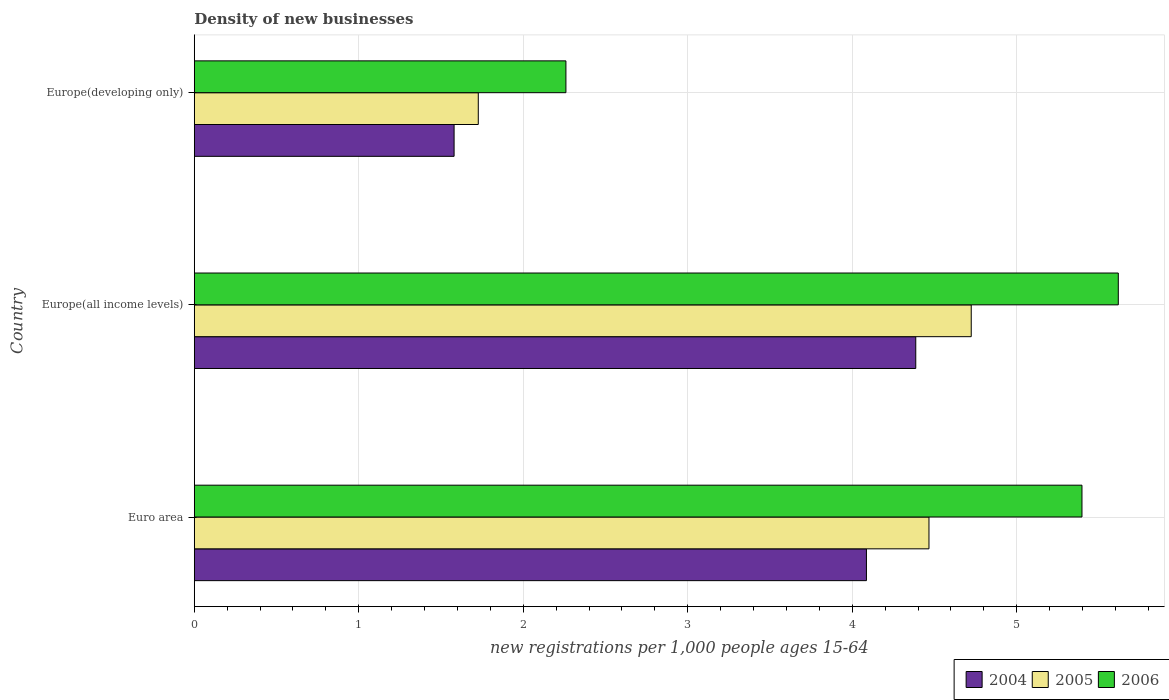How many groups of bars are there?
Make the answer very short. 3. Are the number of bars per tick equal to the number of legend labels?
Your answer should be compact. Yes. Are the number of bars on each tick of the Y-axis equal?
Keep it short and to the point. Yes. What is the label of the 1st group of bars from the top?
Your response must be concise. Europe(developing only). What is the number of new registrations in 2006 in Euro area?
Make the answer very short. 5.4. Across all countries, what is the maximum number of new registrations in 2006?
Provide a succinct answer. 5.62. Across all countries, what is the minimum number of new registrations in 2004?
Provide a short and direct response. 1.58. In which country was the number of new registrations in 2004 maximum?
Keep it short and to the point. Europe(all income levels). In which country was the number of new registrations in 2005 minimum?
Your answer should be very brief. Europe(developing only). What is the total number of new registrations in 2004 in the graph?
Your answer should be compact. 10.05. What is the difference between the number of new registrations in 2006 in Euro area and that in Europe(developing only)?
Provide a succinct answer. 3.14. What is the difference between the number of new registrations in 2005 in Euro area and the number of new registrations in 2004 in Europe(all income levels)?
Your answer should be very brief. 0.08. What is the average number of new registrations in 2006 per country?
Give a very brief answer. 4.42. What is the difference between the number of new registrations in 2005 and number of new registrations in 2006 in Europe(all income levels)?
Provide a succinct answer. -0.89. What is the ratio of the number of new registrations in 2006 in Europe(all income levels) to that in Europe(developing only)?
Your response must be concise. 2.49. Is the difference between the number of new registrations in 2005 in Europe(all income levels) and Europe(developing only) greater than the difference between the number of new registrations in 2006 in Europe(all income levels) and Europe(developing only)?
Keep it short and to the point. No. What is the difference between the highest and the second highest number of new registrations in 2006?
Offer a very short reply. 0.22. What is the difference between the highest and the lowest number of new registrations in 2006?
Your response must be concise. 3.36. Is the sum of the number of new registrations in 2005 in Euro area and Europe(all income levels) greater than the maximum number of new registrations in 2004 across all countries?
Ensure brevity in your answer.  Yes. What does the 1st bar from the bottom in Europe(all income levels) represents?
Ensure brevity in your answer.  2004. How many bars are there?
Offer a very short reply. 9. Are all the bars in the graph horizontal?
Your answer should be very brief. Yes. How many countries are there in the graph?
Provide a succinct answer. 3. Are the values on the major ticks of X-axis written in scientific E-notation?
Offer a very short reply. No. Does the graph contain any zero values?
Your answer should be compact. No. Where does the legend appear in the graph?
Your answer should be very brief. Bottom right. How many legend labels are there?
Ensure brevity in your answer.  3. What is the title of the graph?
Offer a very short reply. Density of new businesses. What is the label or title of the X-axis?
Your answer should be very brief. New registrations per 1,0 people ages 15-64. What is the label or title of the Y-axis?
Your answer should be compact. Country. What is the new registrations per 1,000 people ages 15-64 in 2004 in Euro area?
Give a very brief answer. 4.09. What is the new registrations per 1,000 people ages 15-64 of 2005 in Euro area?
Offer a very short reply. 4.47. What is the new registrations per 1,000 people ages 15-64 of 2006 in Euro area?
Offer a very short reply. 5.4. What is the new registrations per 1,000 people ages 15-64 in 2004 in Europe(all income levels)?
Provide a short and direct response. 4.39. What is the new registrations per 1,000 people ages 15-64 of 2005 in Europe(all income levels)?
Offer a very short reply. 4.72. What is the new registrations per 1,000 people ages 15-64 in 2006 in Europe(all income levels)?
Provide a succinct answer. 5.62. What is the new registrations per 1,000 people ages 15-64 of 2004 in Europe(developing only)?
Give a very brief answer. 1.58. What is the new registrations per 1,000 people ages 15-64 of 2005 in Europe(developing only)?
Make the answer very short. 1.73. What is the new registrations per 1,000 people ages 15-64 in 2006 in Europe(developing only)?
Your answer should be very brief. 2.26. Across all countries, what is the maximum new registrations per 1,000 people ages 15-64 of 2004?
Your response must be concise. 4.39. Across all countries, what is the maximum new registrations per 1,000 people ages 15-64 of 2005?
Your answer should be very brief. 4.72. Across all countries, what is the maximum new registrations per 1,000 people ages 15-64 of 2006?
Your answer should be compact. 5.62. Across all countries, what is the minimum new registrations per 1,000 people ages 15-64 in 2004?
Your answer should be compact. 1.58. Across all countries, what is the minimum new registrations per 1,000 people ages 15-64 of 2005?
Your answer should be very brief. 1.73. Across all countries, what is the minimum new registrations per 1,000 people ages 15-64 of 2006?
Ensure brevity in your answer.  2.26. What is the total new registrations per 1,000 people ages 15-64 of 2004 in the graph?
Keep it short and to the point. 10.05. What is the total new registrations per 1,000 people ages 15-64 in 2005 in the graph?
Give a very brief answer. 10.92. What is the total new registrations per 1,000 people ages 15-64 in 2006 in the graph?
Make the answer very short. 13.27. What is the difference between the new registrations per 1,000 people ages 15-64 in 2004 in Euro area and that in Europe(all income levels)?
Your answer should be very brief. -0.3. What is the difference between the new registrations per 1,000 people ages 15-64 of 2005 in Euro area and that in Europe(all income levels)?
Give a very brief answer. -0.26. What is the difference between the new registrations per 1,000 people ages 15-64 of 2006 in Euro area and that in Europe(all income levels)?
Provide a succinct answer. -0.22. What is the difference between the new registrations per 1,000 people ages 15-64 of 2004 in Euro area and that in Europe(developing only)?
Make the answer very short. 2.51. What is the difference between the new registrations per 1,000 people ages 15-64 of 2005 in Euro area and that in Europe(developing only)?
Offer a very short reply. 2.74. What is the difference between the new registrations per 1,000 people ages 15-64 of 2006 in Euro area and that in Europe(developing only)?
Offer a terse response. 3.14. What is the difference between the new registrations per 1,000 people ages 15-64 of 2004 in Europe(all income levels) and that in Europe(developing only)?
Give a very brief answer. 2.81. What is the difference between the new registrations per 1,000 people ages 15-64 in 2005 in Europe(all income levels) and that in Europe(developing only)?
Give a very brief answer. 3. What is the difference between the new registrations per 1,000 people ages 15-64 in 2006 in Europe(all income levels) and that in Europe(developing only)?
Ensure brevity in your answer.  3.36. What is the difference between the new registrations per 1,000 people ages 15-64 in 2004 in Euro area and the new registrations per 1,000 people ages 15-64 in 2005 in Europe(all income levels)?
Offer a terse response. -0.64. What is the difference between the new registrations per 1,000 people ages 15-64 of 2004 in Euro area and the new registrations per 1,000 people ages 15-64 of 2006 in Europe(all income levels)?
Keep it short and to the point. -1.53. What is the difference between the new registrations per 1,000 people ages 15-64 of 2005 in Euro area and the new registrations per 1,000 people ages 15-64 of 2006 in Europe(all income levels)?
Provide a short and direct response. -1.15. What is the difference between the new registrations per 1,000 people ages 15-64 of 2004 in Euro area and the new registrations per 1,000 people ages 15-64 of 2005 in Europe(developing only)?
Your answer should be compact. 2.36. What is the difference between the new registrations per 1,000 people ages 15-64 of 2004 in Euro area and the new registrations per 1,000 people ages 15-64 of 2006 in Europe(developing only)?
Your answer should be very brief. 1.83. What is the difference between the new registrations per 1,000 people ages 15-64 in 2005 in Euro area and the new registrations per 1,000 people ages 15-64 in 2006 in Europe(developing only)?
Your answer should be very brief. 2.21. What is the difference between the new registrations per 1,000 people ages 15-64 of 2004 in Europe(all income levels) and the new registrations per 1,000 people ages 15-64 of 2005 in Europe(developing only)?
Make the answer very short. 2.66. What is the difference between the new registrations per 1,000 people ages 15-64 of 2004 in Europe(all income levels) and the new registrations per 1,000 people ages 15-64 of 2006 in Europe(developing only)?
Offer a terse response. 2.13. What is the difference between the new registrations per 1,000 people ages 15-64 of 2005 in Europe(all income levels) and the new registrations per 1,000 people ages 15-64 of 2006 in Europe(developing only)?
Your response must be concise. 2.46. What is the average new registrations per 1,000 people ages 15-64 in 2004 per country?
Offer a terse response. 3.35. What is the average new registrations per 1,000 people ages 15-64 of 2005 per country?
Keep it short and to the point. 3.64. What is the average new registrations per 1,000 people ages 15-64 in 2006 per country?
Your answer should be compact. 4.42. What is the difference between the new registrations per 1,000 people ages 15-64 in 2004 and new registrations per 1,000 people ages 15-64 in 2005 in Euro area?
Ensure brevity in your answer.  -0.38. What is the difference between the new registrations per 1,000 people ages 15-64 in 2004 and new registrations per 1,000 people ages 15-64 in 2006 in Euro area?
Offer a terse response. -1.31. What is the difference between the new registrations per 1,000 people ages 15-64 of 2005 and new registrations per 1,000 people ages 15-64 of 2006 in Euro area?
Offer a terse response. -0.93. What is the difference between the new registrations per 1,000 people ages 15-64 in 2004 and new registrations per 1,000 people ages 15-64 in 2005 in Europe(all income levels)?
Provide a succinct answer. -0.34. What is the difference between the new registrations per 1,000 people ages 15-64 of 2004 and new registrations per 1,000 people ages 15-64 of 2006 in Europe(all income levels)?
Provide a succinct answer. -1.23. What is the difference between the new registrations per 1,000 people ages 15-64 in 2005 and new registrations per 1,000 people ages 15-64 in 2006 in Europe(all income levels)?
Your answer should be very brief. -0.89. What is the difference between the new registrations per 1,000 people ages 15-64 in 2004 and new registrations per 1,000 people ages 15-64 in 2005 in Europe(developing only)?
Give a very brief answer. -0.15. What is the difference between the new registrations per 1,000 people ages 15-64 in 2004 and new registrations per 1,000 people ages 15-64 in 2006 in Europe(developing only)?
Provide a succinct answer. -0.68. What is the difference between the new registrations per 1,000 people ages 15-64 in 2005 and new registrations per 1,000 people ages 15-64 in 2006 in Europe(developing only)?
Your response must be concise. -0.53. What is the ratio of the new registrations per 1,000 people ages 15-64 of 2004 in Euro area to that in Europe(all income levels)?
Make the answer very short. 0.93. What is the ratio of the new registrations per 1,000 people ages 15-64 in 2005 in Euro area to that in Europe(all income levels)?
Make the answer very short. 0.95. What is the ratio of the new registrations per 1,000 people ages 15-64 of 2006 in Euro area to that in Europe(all income levels)?
Your answer should be very brief. 0.96. What is the ratio of the new registrations per 1,000 people ages 15-64 in 2004 in Euro area to that in Europe(developing only)?
Your response must be concise. 2.59. What is the ratio of the new registrations per 1,000 people ages 15-64 in 2005 in Euro area to that in Europe(developing only)?
Offer a terse response. 2.59. What is the ratio of the new registrations per 1,000 people ages 15-64 of 2006 in Euro area to that in Europe(developing only)?
Make the answer very short. 2.39. What is the ratio of the new registrations per 1,000 people ages 15-64 in 2004 in Europe(all income levels) to that in Europe(developing only)?
Offer a very short reply. 2.78. What is the ratio of the new registrations per 1,000 people ages 15-64 of 2005 in Europe(all income levels) to that in Europe(developing only)?
Your response must be concise. 2.74. What is the ratio of the new registrations per 1,000 people ages 15-64 in 2006 in Europe(all income levels) to that in Europe(developing only)?
Your response must be concise. 2.49. What is the difference between the highest and the second highest new registrations per 1,000 people ages 15-64 in 2004?
Your answer should be compact. 0.3. What is the difference between the highest and the second highest new registrations per 1,000 people ages 15-64 of 2005?
Keep it short and to the point. 0.26. What is the difference between the highest and the second highest new registrations per 1,000 people ages 15-64 of 2006?
Keep it short and to the point. 0.22. What is the difference between the highest and the lowest new registrations per 1,000 people ages 15-64 of 2004?
Offer a very short reply. 2.81. What is the difference between the highest and the lowest new registrations per 1,000 people ages 15-64 in 2005?
Your answer should be very brief. 3. What is the difference between the highest and the lowest new registrations per 1,000 people ages 15-64 in 2006?
Provide a succinct answer. 3.36. 